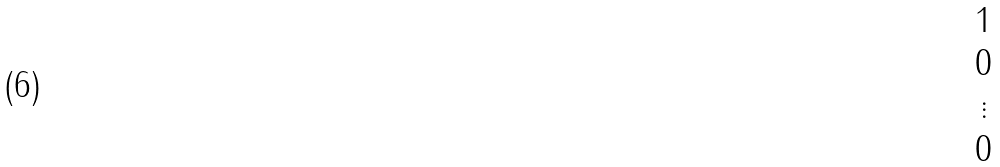<formula> <loc_0><loc_0><loc_500><loc_500>\begin{matrix} 1 \\ 0 \\ \vdots \\ 0 \end{matrix}</formula> 